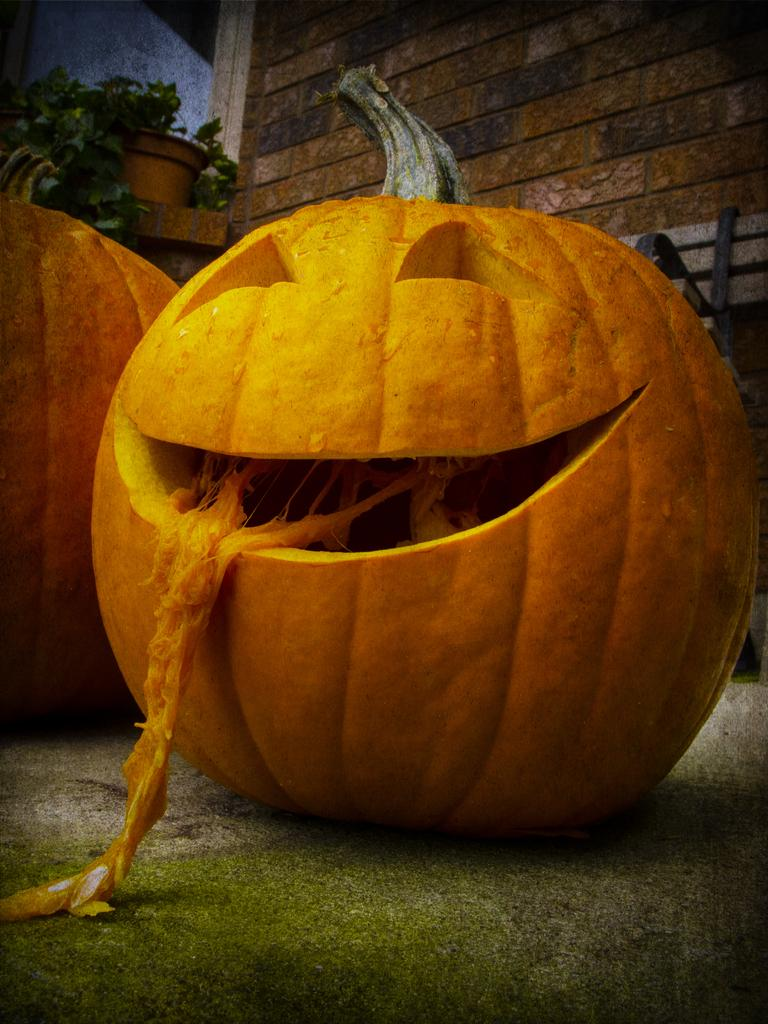What objects are on the ground in the image? There are pumpkins on the ground in the image. What can be seen in the background of the image? There is a wall visible in the image. What is in the pot in the image? There is a plant in the pot in the image. What type of leather is being used to make the pencil in the image? There is no pencil present in the image, so it is not possible to determine what type of leather might be used. 